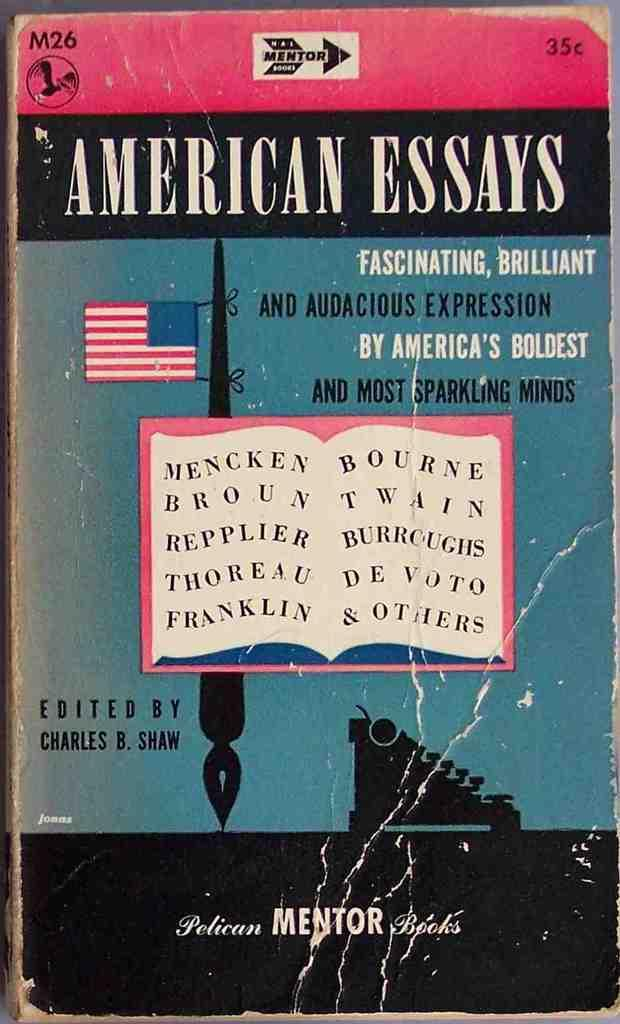Provide a one-sentence caption for the provided image. A battered book with American Essays written on the front. 